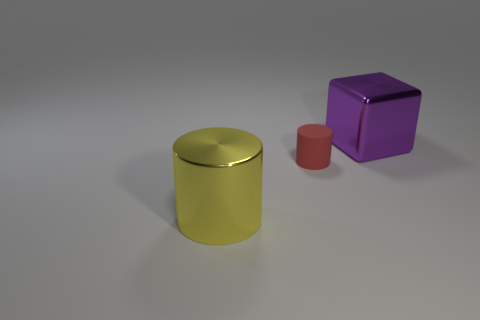Are there any other things that have the same material as the red cylinder?
Your answer should be very brief. No. There is another thing that is the same shape as the red object; what is its material?
Provide a short and direct response. Metal. Is there anything else that is the same size as the red object?
Give a very brief answer. No. Are any large purple blocks visible?
Provide a succinct answer. Yes. The tiny cylinder in front of the large shiny object behind the big object left of the tiny rubber cylinder is made of what material?
Ensure brevity in your answer.  Rubber. Does the yellow metallic object have the same shape as the small matte object that is on the right side of the large yellow metallic thing?
Your answer should be compact. Yes. How many other tiny things have the same shape as the yellow thing?
Provide a succinct answer. 1. What is the shape of the yellow shiny thing?
Your answer should be very brief. Cylinder. There is a cylinder that is behind the cylinder on the left side of the tiny cylinder; what is its size?
Offer a terse response. Small. What number of things are big gray rubber spheres or metallic objects?
Provide a short and direct response. 2. 